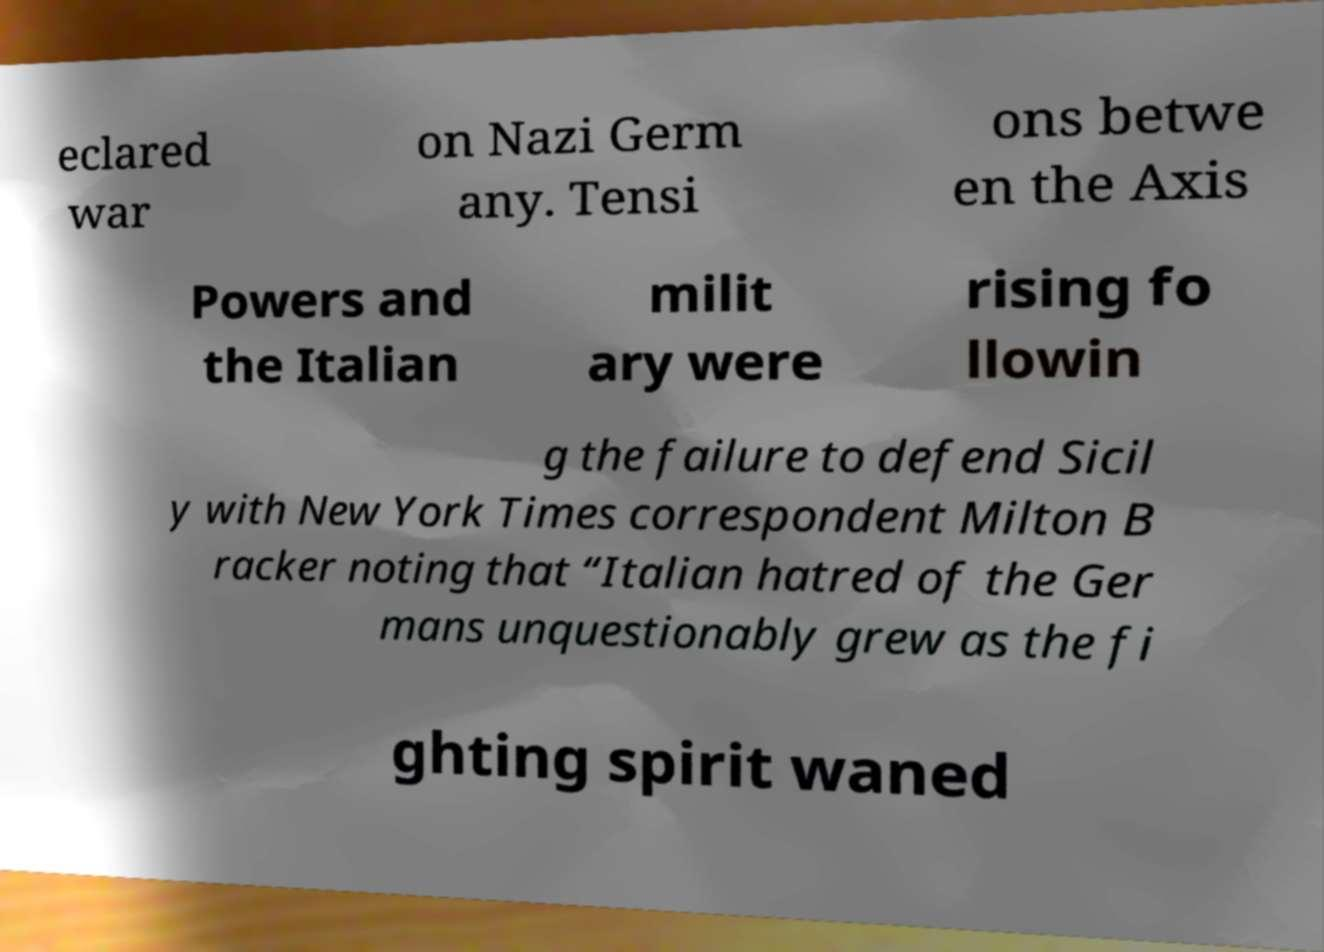Could you extract and type out the text from this image? eclared war on Nazi Germ any. Tensi ons betwe en the Axis Powers and the Italian milit ary were rising fo llowin g the failure to defend Sicil y with New York Times correspondent Milton B racker noting that “Italian hatred of the Ger mans unquestionably grew as the fi ghting spirit waned 